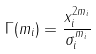Convert formula to latex. <formula><loc_0><loc_0><loc_500><loc_500>\Gamma ( m _ { i } ) = \frac { x _ { i } ^ { 2 m _ { i } } } { \sigma _ { i } ^ { m _ { i } } }</formula> 